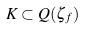<formula> <loc_0><loc_0><loc_500><loc_500>K \subset Q ( \zeta _ { f } )</formula> 